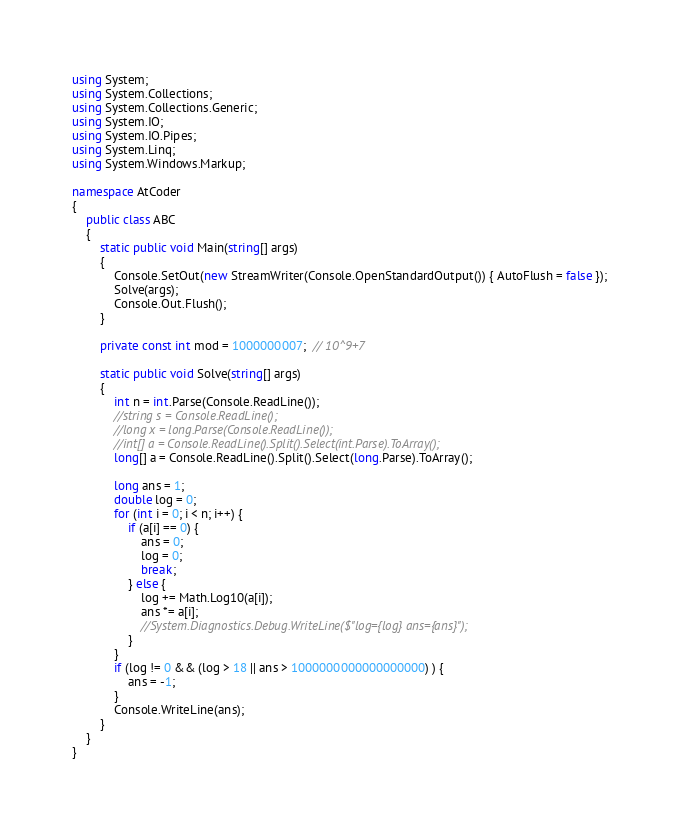Convert code to text. <code><loc_0><loc_0><loc_500><loc_500><_C#_>using System;
using System.Collections;
using System.Collections.Generic;
using System.IO;
using System.IO.Pipes;
using System.Linq;
using System.Windows.Markup;

namespace AtCoder
{
	public class ABC
	{
		static public void Main(string[] args)
		{
			Console.SetOut(new StreamWriter(Console.OpenStandardOutput()) { AutoFlush = false });
			Solve(args);
			Console.Out.Flush();
		}

		private const int mod = 1000000007;  // 10^9+7

		static public void Solve(string[] args)
		{
			int n = int.Parse(Console.ReadLine());
			//string s = Console.ReadLine();
			//long x = long.Parse(Console.ReadLine());
			//int[] a = Console.ReadLine().Split().Select(int.Parse).ToArray();
			long[] a = Console.ReadLine().Split().Select(long.Parse).ToArray();

			long ans = 1;
			double log = 0;
			for (int i = 0; i < n; i++) {
				if (a[i] == 0) {
					ans = 0;
					log = 0;
					break;
				} else {
					log += Math.Log10(a[i]);
					ans *= a[i];
					//System.Diagnostics.Debug.WriteLine($"log={log} ans={ans}");
				}
			}
			if (log != 0 && (log > 18 || ans > 1000000000000000000) ) {
				ans = -1;
			}
			Console.WriteLine(ans);
		}
	}
}
</code> 